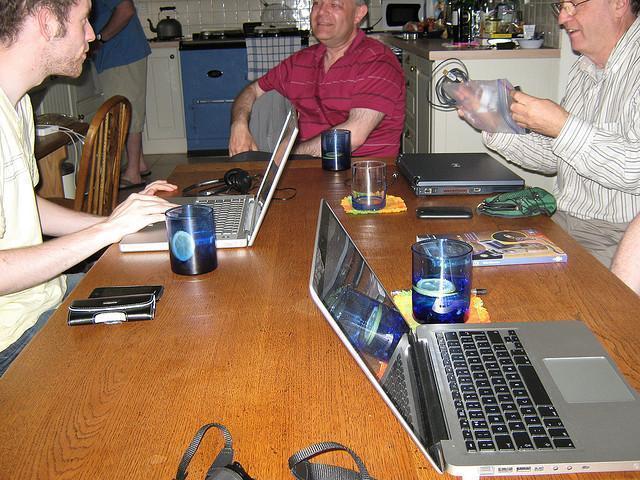Why is everyone at the table using laptops?
From the following set of four choices, select the accurate answer to respond to the question.
Options: They're hackers, they're repairmen, they're criminals, they're working. They're working. 